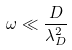Convert formula to latex. <formula><loc_0><loc_0><loc_500><loc_500>\omega \ll \frac { D } { \lambda _ { D } ^ { 2 } }</formula> 